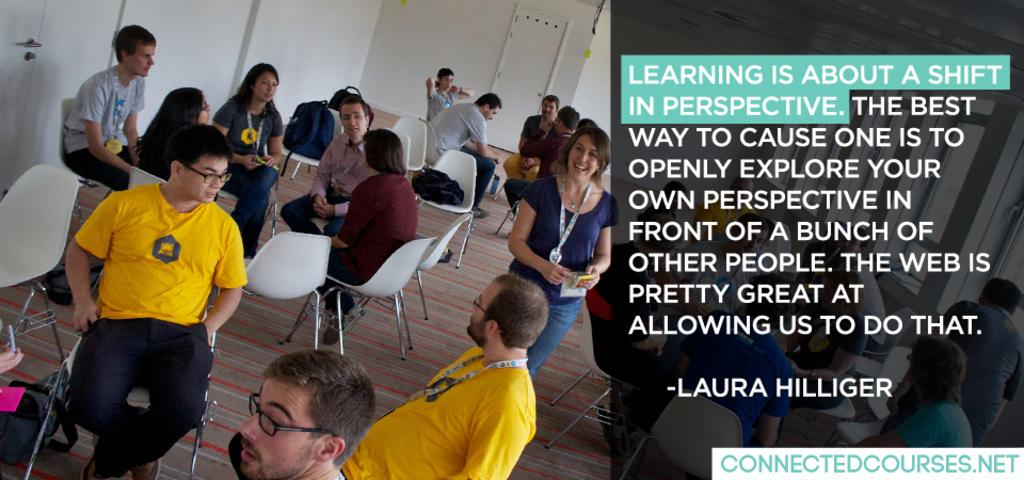What are the people in the image doing? There are people sitting in chairs and people standing in the image. What is placed on the chairs in the image? There are bags on the chairs in the image. Where can text be found in the image? Text is located on the right side of the image. Can you tell me how many caps are being worn by the people in the image? There is no mention of caps or any headwear in the provided facts, so it cannot be determined from the image. 